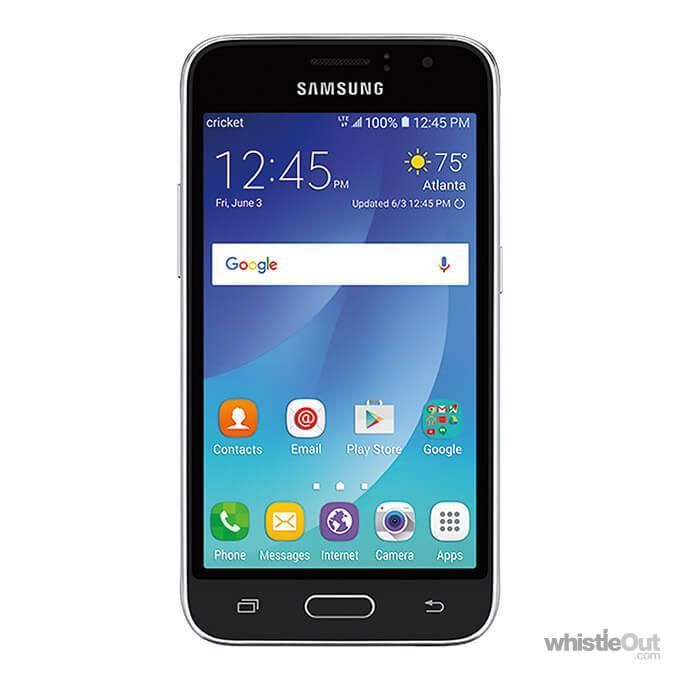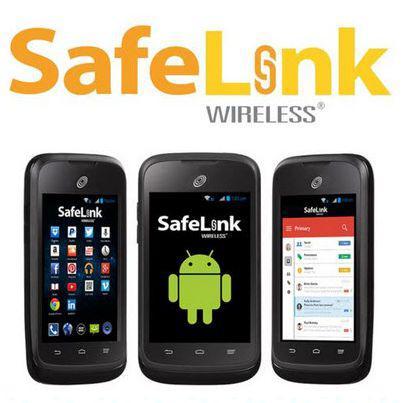The first image is the image on the left, the second image is the image on the right. Assess this claim about the two images: "The back of a phone is completely visible.". Correct or not? Answer yes or no. No. The first image is the image on the left, the second image is the image on the right. Evaluate the accuracy of this statement regarding the images: "There is  total of four phones with the right side having more.". Is it true? Answer yes or no. Yes. 